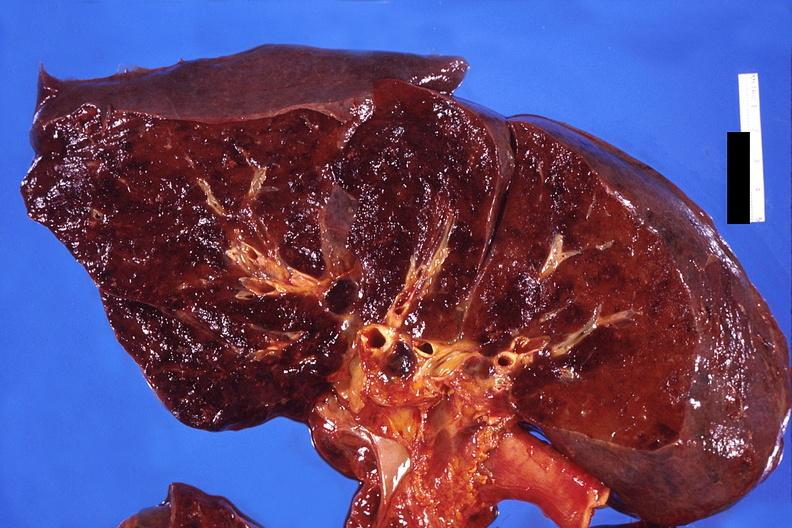s respiratory present?
Answer the question using a single word or phrase. Yes 